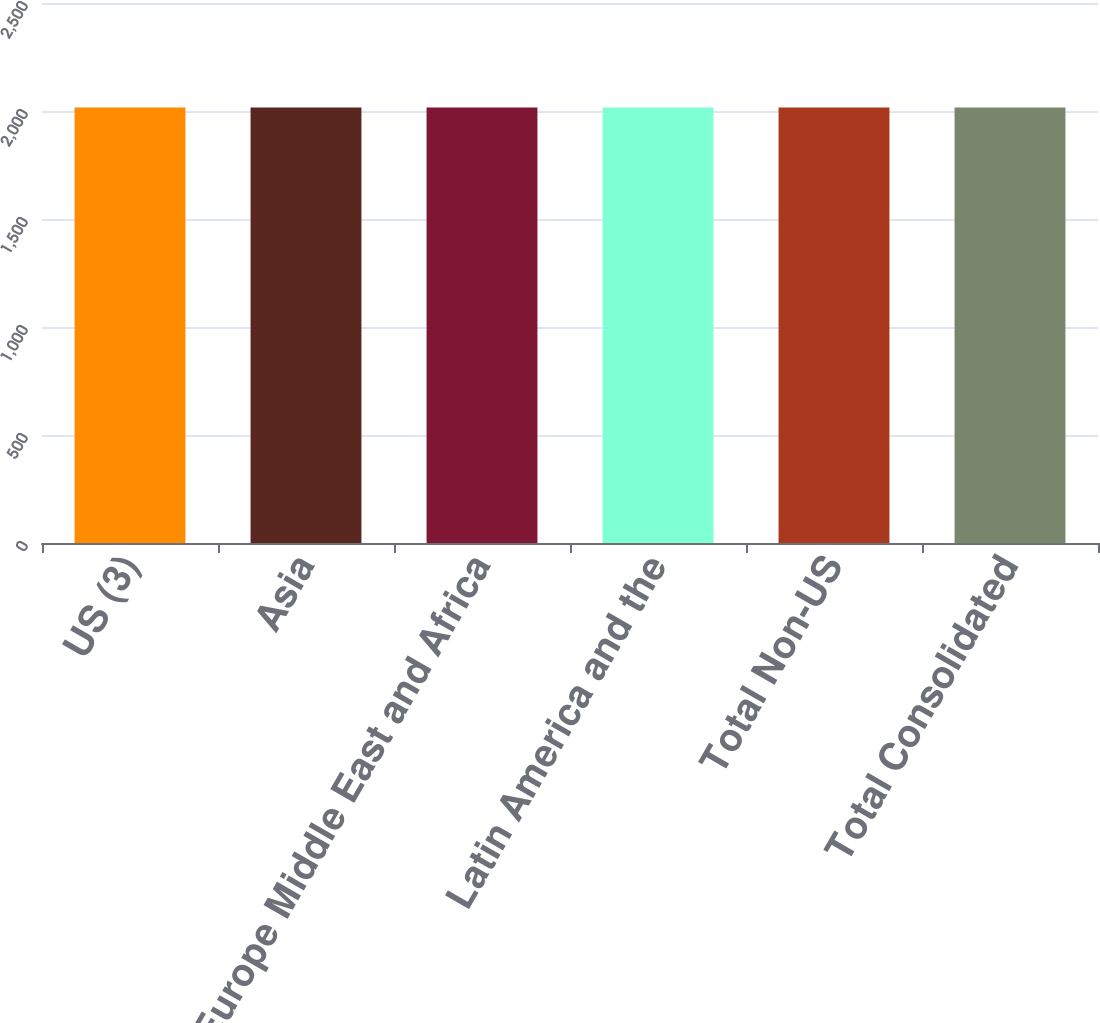<chart> <loc_0><loc_0><loc_500><loc_500><bar_chart><fcel>US (3)<fcel>Asia<fcel>Europe Middle East and Africa<fcel>Latin America and the<fcel>Total Non-US<fcel>Total Consolidated<nl><fcel>2016<fcel>2016.1<fcel>2016.2<fcel>2016.3<fcel>2016.4<fcel>2016.5<nl></chart> 